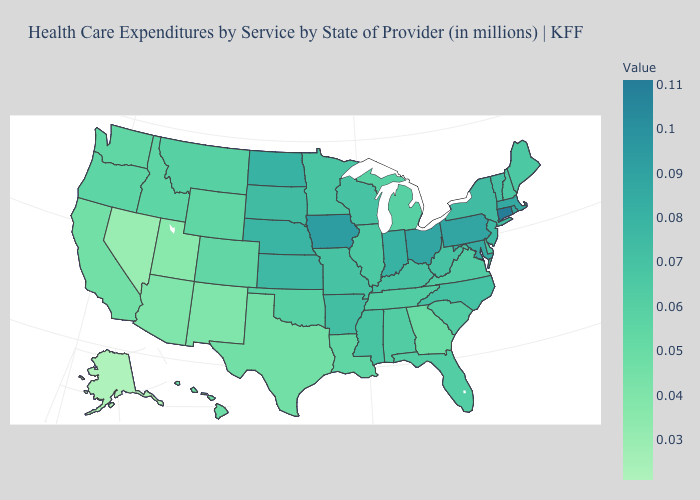Does the map have missing data?
Answer briefly. No. Does Missouri have the lowest value in the USA?
Short answer required. No. Is the legend a continuous bar?
Keep it brief. Yes. Does Arkansas have the lowest value in the South?
Give a very brief answer. No. 